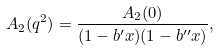<formula> <loc_0><loc_0><loc_500><loc_500>A _ { 2 } ( q ^ { 2 } ) = \frac { A _ { 2 } ( 0 ) } { ( 1 - b ^ { \prime } x ) ( 1 - b ^ { \prime \prime } x ) } ,</formula> 